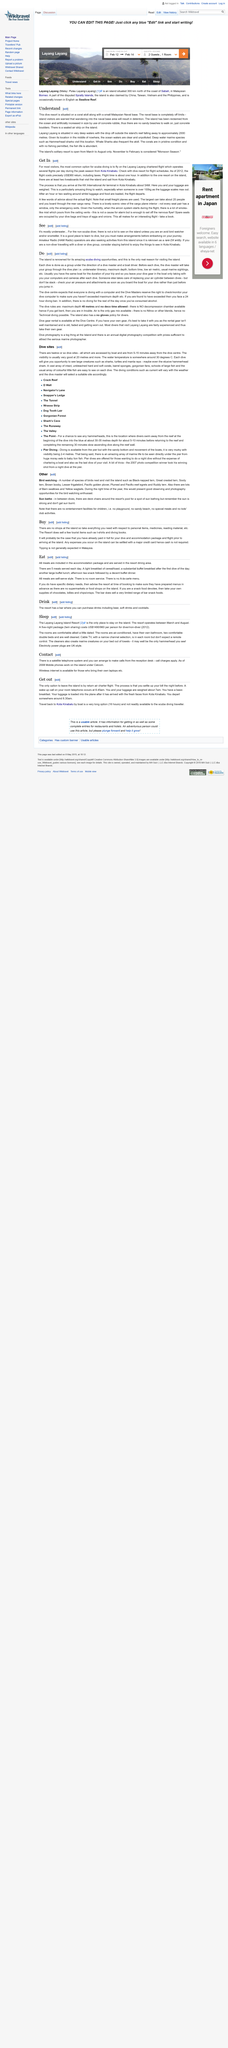Mention a couple of crucial points in this snapshot. The island's solitary resort is open from March to August only. The drive resort is located on a coral atoll along with a small Malaysian naval base. The Layang Layang is located in very deep waters. 